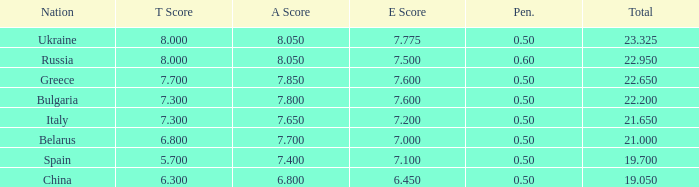What's the sum of A Score that also has a score lower than 7.3 and an E Score larger than 7.1? None. Write the full table. {'header': ['Nation', 'T Score', 'A Score', 'E Score', 'Pen.', 'Total'], 'rows': [['Ukraine', '8.000', '8.050', '7.775', '0.50', '23.325'], ['Russia', '8.000', '8.050', '7.500', '0.60', '22.950'], ['Greece', '7.700', '7.850', '7.600', '0.50', '22.650'], ['Bulgaria', '7.300', '7.800', '7.600', '0.50', '22.200'], ['Italy', '7.300', '7.650', '7.200', '0.50', '21.650'], ['Belarus', '6.800', '7.700', '7.000', '0.50', '21.000'], ['Spain', '5.700', '7.400', '7.100', '0.50', '19.700'], ['China', '6.300', '6.800', '6.450', '0.50', '19.050']]} 